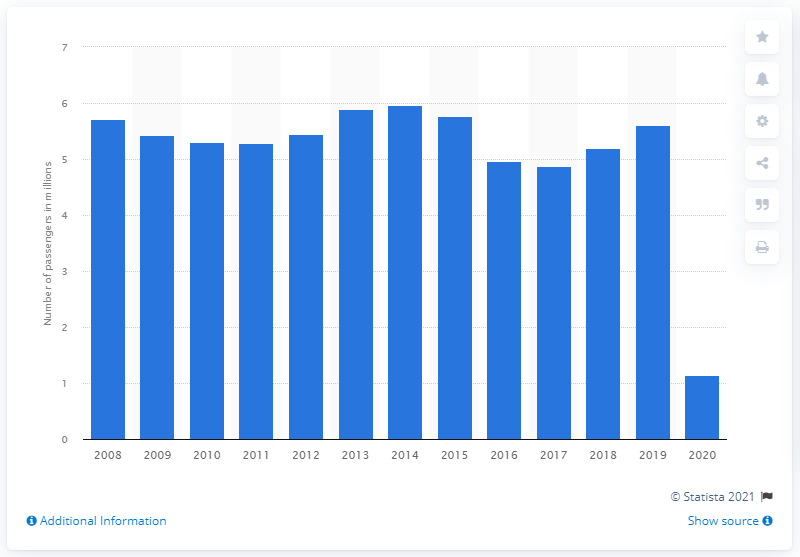List a handful of essential elements in this visual. Virgin Atlantic Airways transported 1.14 million passengers in 2020. 